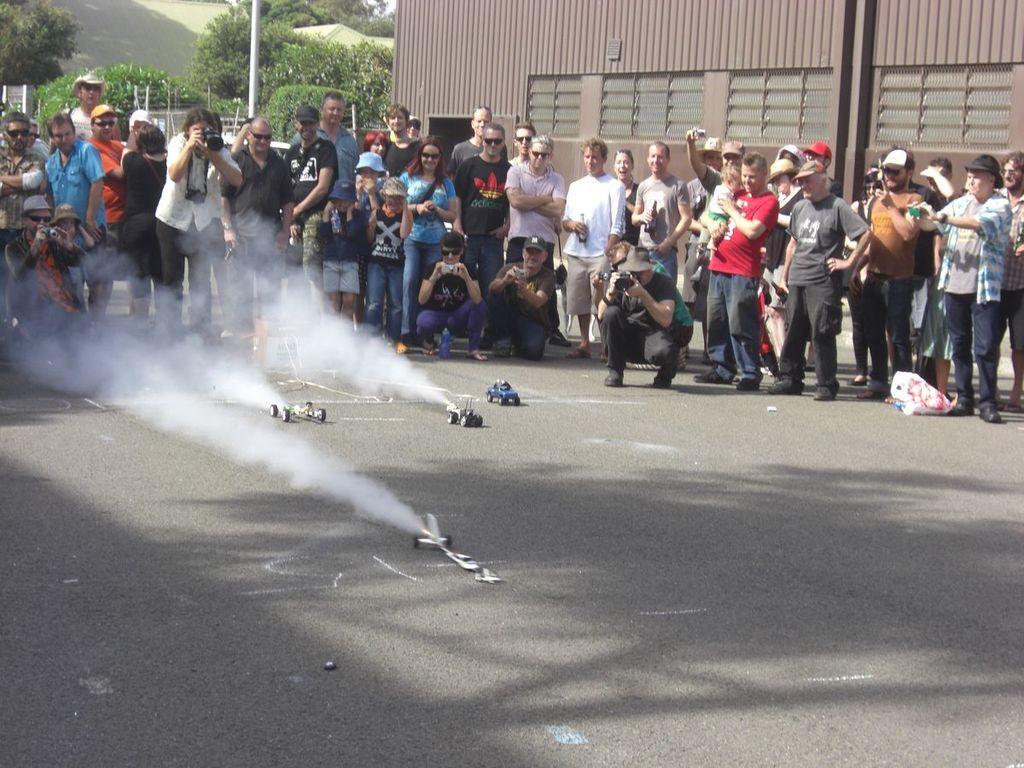Can you describe this image briefly? In this image I can see the ground, few toy vehicles on the ground and number few persons are standing and sitting. I can see few of them are holding cameras in their hands. In the background I can see few trees, few buildings, few poles and the sky. 